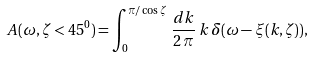Convert formula to latex. <formula><loc_0><loc_0><loc_500><loc_500>A ( \omega , \zeta < 4 5 ^ { 0 } ) = \int _ { 0 } ^ { \pi / \cos \zeta } \, \frac { d k } { 2 \, \pi } \, k \, \delta ( \omega - \xi ( k , \zeta ) ) ,</formula> 